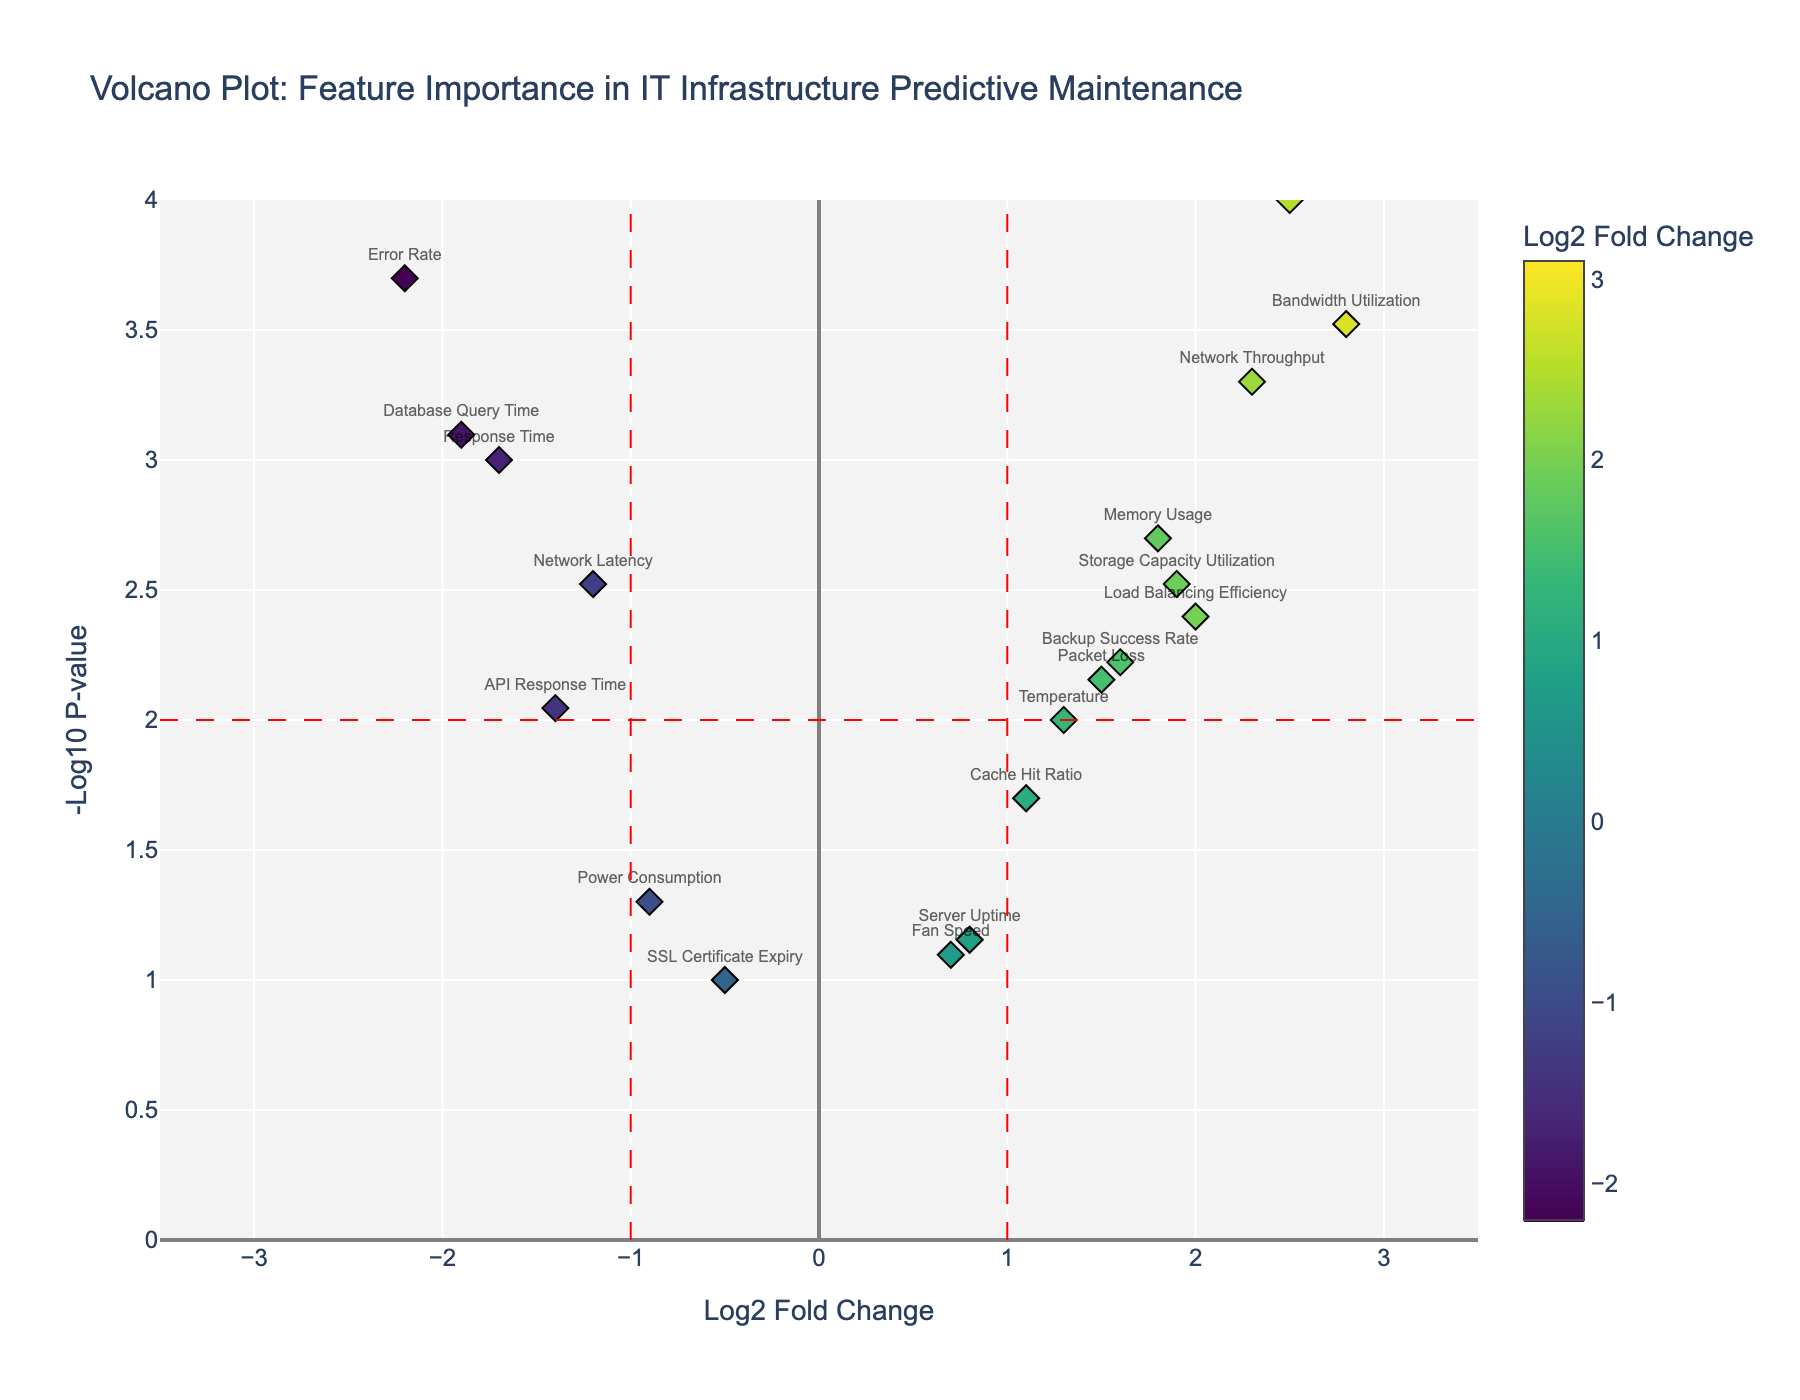What is the title of the plot? The title is usually placed at the top of the plot. In this case, it reads "Volcano Plot: Feature Importance in IT Infrastructure Predictive Maintenance".
Answer: Volcano Plot: Feature Importance in IT Infrastructure Predictive Maintenance Which feature shows the highest log2 fold change? By looking at the x-axis representing log2 fold change, Disk I/O is farthest to the right with a log2 fold change of 3.1.
Answer: Disk I/O How many features have a p-value less than 0.01? Features with a p-value less than 0.01 will have a -log10 p-value greater than 2. By counting data points in the figure with y-axis values above 2, we find there are 9 features.
Answer: 9 Which feature has the lowest p-value? The lowest p-value corresponds to the highest point on the y-axis (-log10_p_value). Disk I/O is the highest point with a very small p-value of 0.00005.
Answer: Disk I/O How does Network Latency compare to CPU Utilization in terms of log2 fold change? Network Latency has a log2 fold change of -1.2 while CPU Utilization has a log2 fold change of 2.5. CPU Utilization has a higher (more positive) log2 fold change.
Answer: CPU Utilization has a higher log2 fold change What is the difference in log2 fold change between Memory Usage and SSL Certificate Expiry? Memory Usage has a log2 fold change of 1.8, and SSL Certificate Expiry has a log2 fold change of -0.5. The difference is 1.8 - (-0.5) = 2.3.
Answer: 2.3 How many features have a log2 fold change greater than 1? By observing the x-axis, count the number of data points to the right of the line at log2 fold change equals 1. There are 10 such features.
Answer: 10 Which feature has a -log10 p-value of exactly 4? In the plot, Disk I/O has the highest -log10 p-value, which is exactly 4.
Answer: Disk I/O Is there any feature that shows a negative log2 fold change and a p-value less than 0.01? Negative log2 fold change is found on the left side of the vertical line at 0, and p-value less than 0.01 corresponds to points with -log10 p-value greater than 2. Error Rate, Response Time, and Database Query Time fall in this category.
Answer: Error Rate, Response Time, Database Query Time Which feature has almost the same log2 fold change as Bandwidth Utilization but a higher p-value? By comparing the x-axis and y-axis values, Network Throughput has a similar log2 fold change to Bandwidth Utilization but a higher p-value (leading to a lower -log10 p-value).
Answer: Network Throughput 